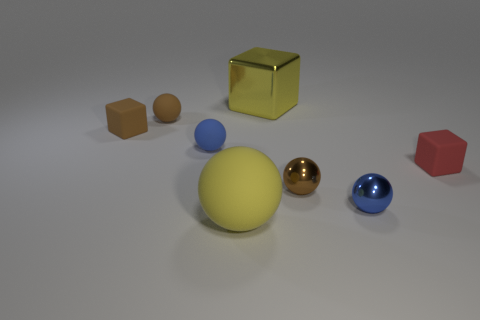What is the shape of the other large object that is the same color as the big metallic thing?
Ensure brevity in your answer.  Sphere. What number of other things have the same color as the big metallic object?
Your response must be concise. 1. The big rubber ball is what color?
Keep it short and to the point. Yellow. Is the yellow ball the same size as the yellow shiny object?
Offer a terse response. Yes. How many things are big purple matte cubes or blue shiny things?
Give a very brief answer. 1. Are there the same number of big yellow rubber spheres behind the yellow sphere and small gray rubber cylinders?
Your response must be concise. Yes. Are there any rubber balls in front of the small matte block that is on the right side of the metallic thing behind the red matte cube?
Make the answer very short. Yes. The large ball that is made of the same material as the tiny red cube is what color?
Keep it short and to the point. Yellow. There is a large shiny object on the right side of the tiny brown matte cube; is it the same color as the big matte sphere?
Your response must be concise. Yes. What number of blocks are either gray shiny things or brown rubber things?
Offer a very short reply. 1. 